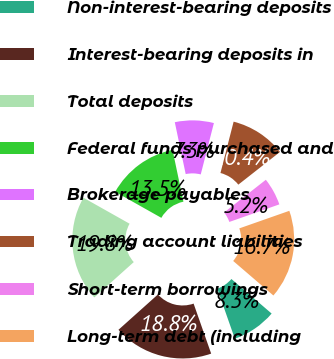Convert chart. <chart><loc_0><loc_0><loc_500><loc_500><pie_chart><fcel>Non-interest-bearing deposits<fcel>Interest-bearing deposits in<fcel>Total deposits<fcel>Federal funds purchased and<fcel>Brokerage payables<fcel>Trading account liabilities<fcel>Short-term borrowings<fcel>Long-term debt (including<nl><fcel>8.33%<fcel>18.75%<fcel>19.79%<fcel>13.54%<fcel>7.29%<fcel>10.42%<fcel>5.21%<fcel>16.67%<nl></chart> 